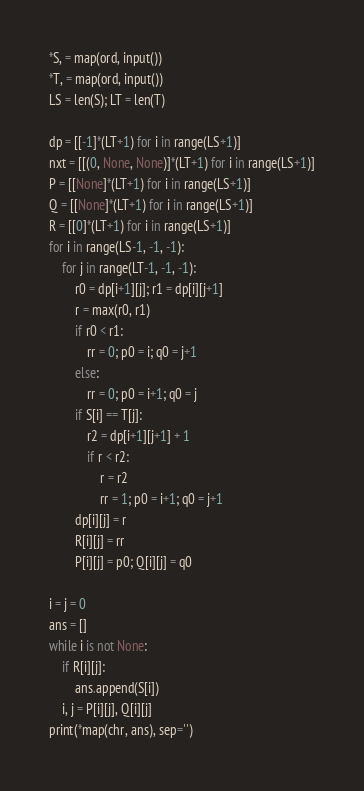Convert code to text. <code><loc_0><loc_0><loc_500><loc_500><_Python_>*S, = map(ord, input())
*T, = map(ord, input())
LS = len(S); LT = len(T)

dp = [[-1]*(LT+1) for i in range(LS+1)]
nxt = [[(0, None, None)]*(LT+1) for i in range(LS+1)]
P = [[None]*(LT+1) for i in range(LS+1)]
Q = [[None]*(LT+1) for i in range(LS+1)]
R = [[0]*(LT+1) for i in range(LS+1)]
for i in range(LS-1, -1, -1):
    for j in range(LT-1, -1, -1):
        r0 = dp[i+1][j]; r1 = dp[i][j+1]
        r = max(r0, r1)
        if r0 < r1:
            rr = 0; p0 = i; q0 = j+1
        else:
            rr = 0; p0 = i+1; q0 = j
        if S[i] == T[j]:
            r2 = dp[i+1][j+1] + 1
            if r < r2:
                r = r2
                rr = 1; p0 = i+1; q0 = j+1
        dp[i][j] = r
        R[i][j] = rr
        P[i][j] = p0; Q[i][j] = q0

i = j = 0
ans = []
while i is not None:
    if R[i][j]:
        ans.append(S[i])
    i, j = P[i][j], Q[i][j]
print(*map(chr, ans), sep='')</code> 